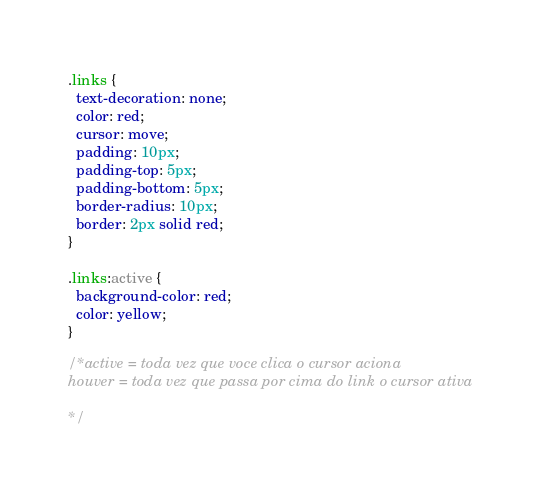Convert code to text. <code><loc_0><loc_0><loc_500><loc_500><_CSS_>.links {
  text-decoration: none;
  color: red;
  cursor: move;
  padding: 10px;
  padding-top: 5px;
  padding-bottom: 5px;
  border-radius: 10px;
  border: 2px solid red;
}

.links:active {
  background-color: red;
  color: yellow;
}

/*active = toda vez que voce clica o cursor aciona
houver = toda vez que passa por cima do link o cursor ativa

*/


</code> 